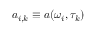Convert formula to latex. <formula><loc_0><loc_0><loc_500><loc_500>a _ { i , k } \equiv a ( \omega _ { i } , \tau _ { k } )</formula> 